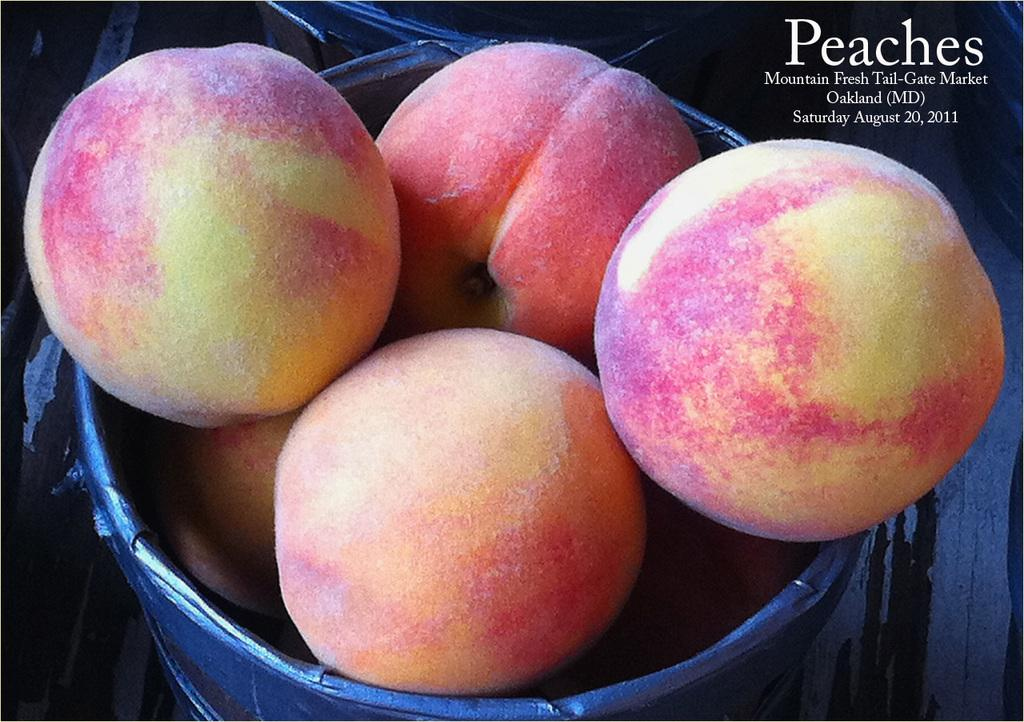How many baskets are visible in the image? There are two baskets in the image. What is in one of the baskets? There are peaches in one of the baskets. Can you describe the object on the surface of the image? Unfortunately, the facts provided do not give any information about the object on the surface of the image. Where is the text located in the image? The text is in the right top corner of the image. What type of cheese is being grated by the thumb in the image? There is no thumb or cheese present in the image. 